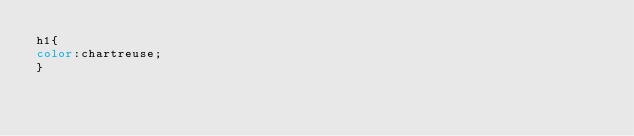<code> <loc_0><loc_0><loc_500><loc_500><_CSS_>h1{
color:chartreuse;
}
</code> 